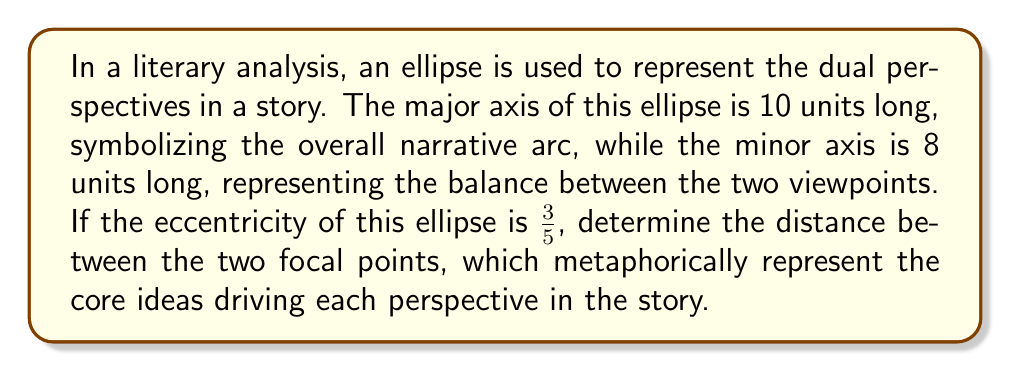Can you solve this math problem? Let's approach this step-by-step:

1) In an ellipse, we have the following relationship:
   $$a^2 = b^2 + c^2$$
   where $a$ is half the major axis, $b$ is half the minor axis, and $c$ is the distance from the center to a focus.

2) We're given that the major axis is 10 units, so $a = 5$.
   The minor axis is 8 units, so $b = 4$.

3) The eccentricity $e$ is defined as $e = \frac{c}{a}$, and we're told it's $\frac{3}{5}$.

4) From the eccentricity, we can find $c$:
   $$\frac{3}{5} = \frac{c}{5}$$
   $$c = 3$$

5) The distance between the focal points is $2c$.

6) Therefore, the distance between the focal points is $2 * 3 = 6$ units.

We can verify this using the equation from step 1:
$$5^2 = 4^2 + 3^2$$
$$25 = 16 + 9$$
$$25 = 25$$

This confirms our calculation.
Answer: 6 units 